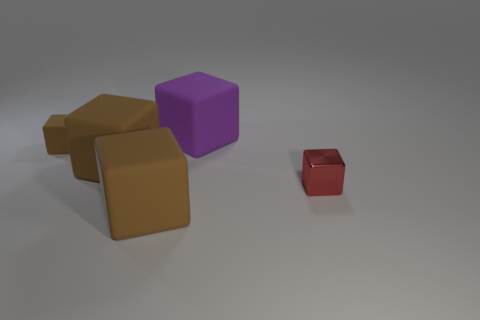Subtract all blue spheres. How many brown cubes are left? 3 Subtract 2 cubes. How many cubes are left? 3 Subtract all purple blocks. How many blocks are left? 4 Subtract all purple rubber blocks. How many blocks are left? 4 Subtract all blue blocks. Subtract all blue cylinders. How many blocks are left? 5 Add 2 small red cubes. How many objects exist? 7 Subtract 0 cyan blocks. How many objects are left? 5 Subtract all big matte things. Subtract all big red rubber cylinders. How many objects are left? 2 Add 5 big rubber objects. How many big rubber objects are left? 8 Add 1 small red metal cubes. How many small red metal cubes exist? 2 